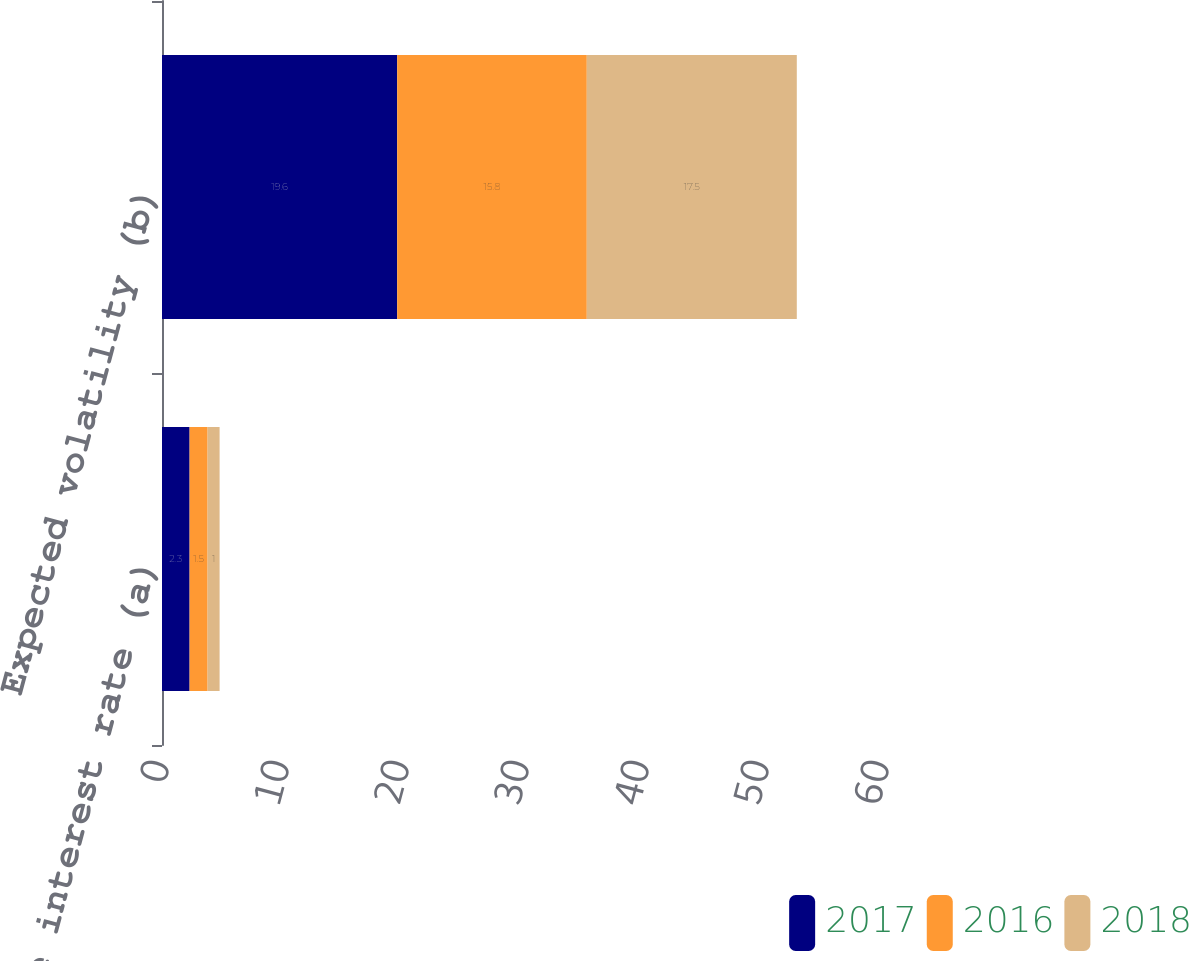<chart> <loc_0><loc_0><loc_500><loc_500><stacked_bar_chart><ecel><fcel>Risk-free interest rate (a)<fcel>Expected volatility (b)<nl><fcel>2017<fcel>2.3<fcel>19.6<nl><fcel>2016<fcel>1.5<fcel>15.8<nl><fcel>2018<fcel>1<fcel>17.5<nl></chart> 